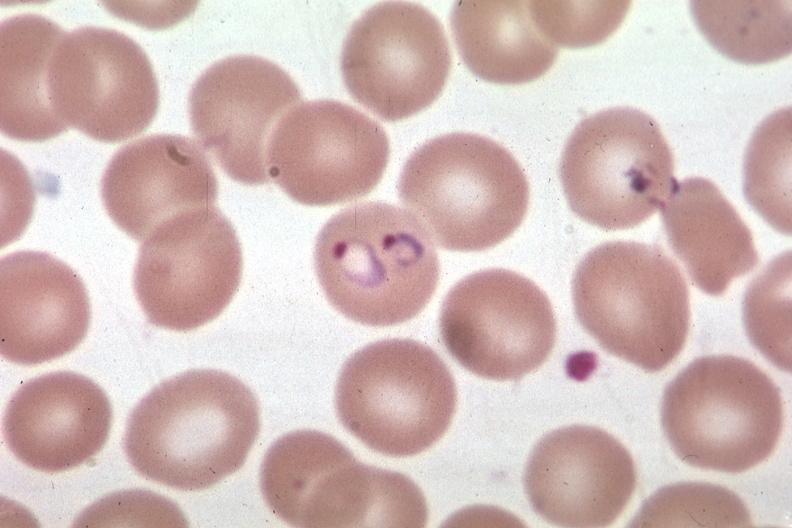s blood present?
Answer the question using a single word or phrase. Yes 